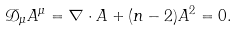<formula> <loc_0><loc_0><loc_500><loc_500>\mathcal { D } _ { \mu } A ^ { \mu } = \nabla \cdot A + ( n - 2 ) A ^ { 2 } = 0 .</formula> 